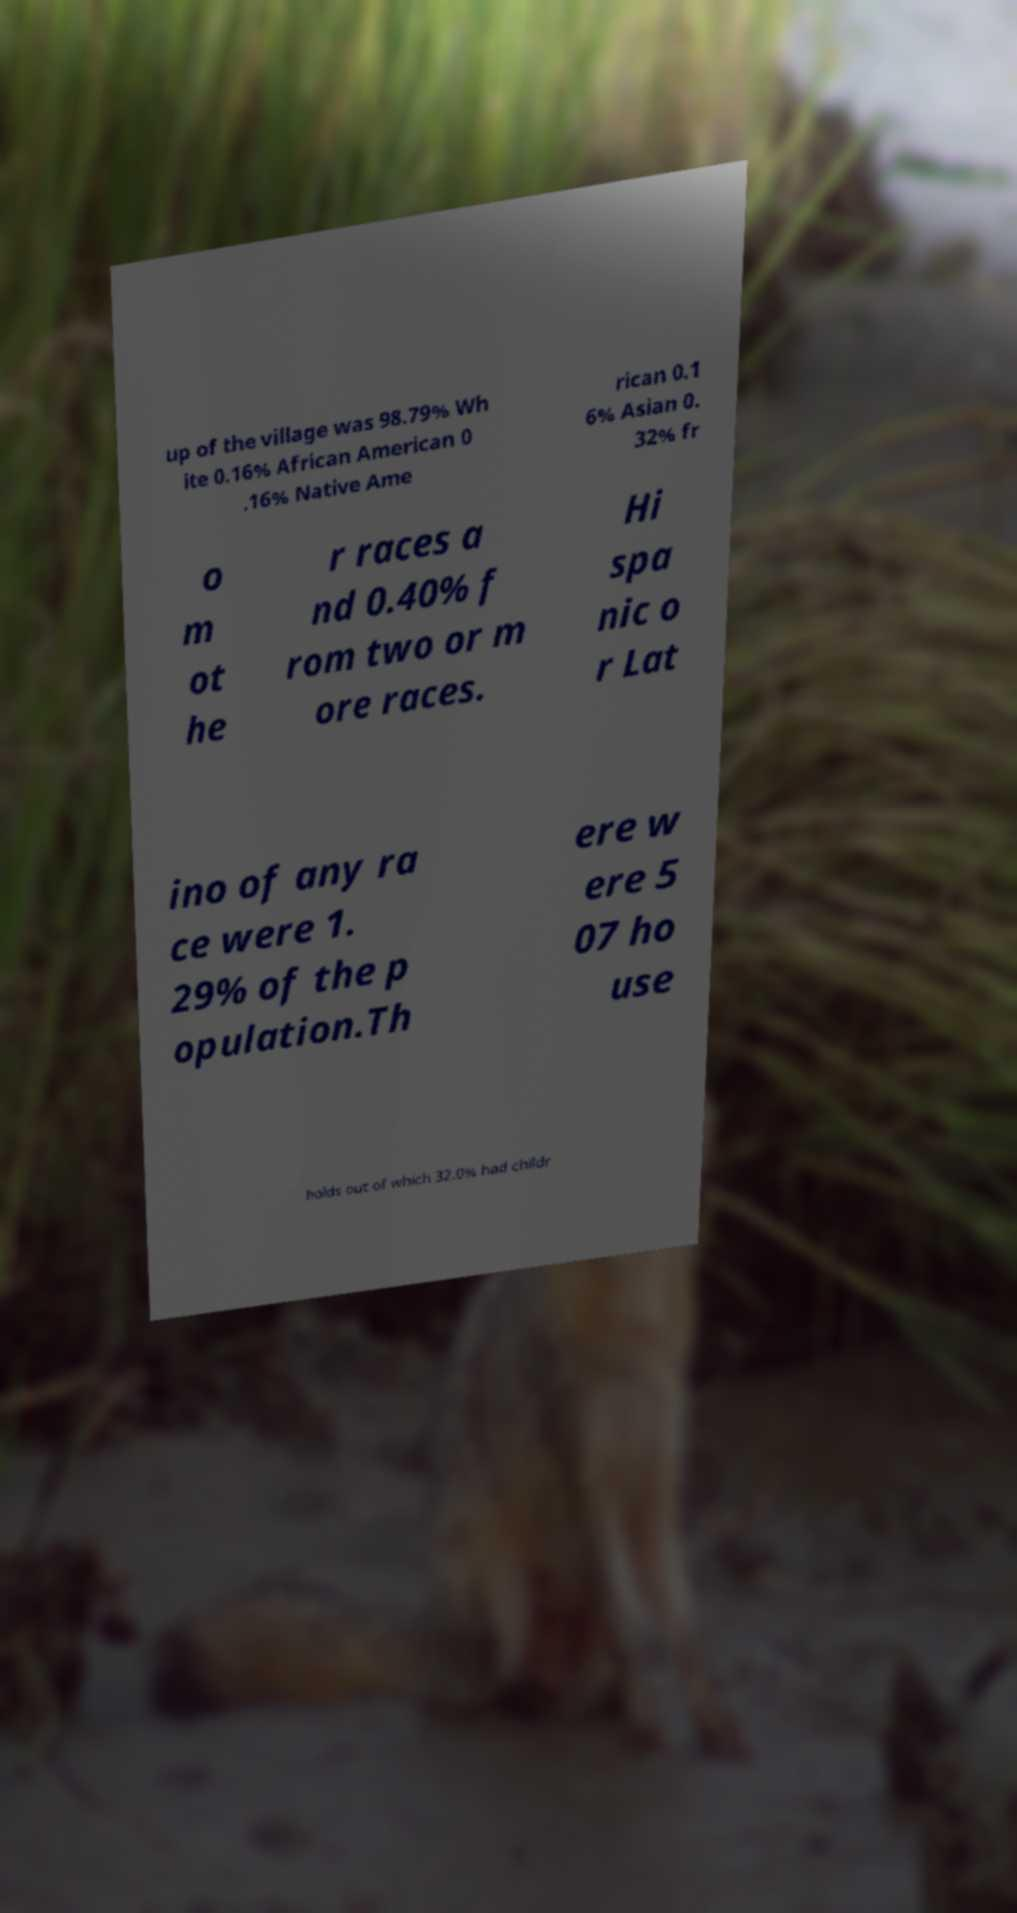Please read and relay the text visible in this image. What does it say? up of the village was 98.79% Wh ite 0.16% African American 0 .16% Native Ame rican 0.1 6% Asian 0. 32% fr o m ot he r races a nd 0.40% f rom two or m ore races. Hi spa nic o r Lat ino of any ra ce were 1. 29% of the p opulation.Th ere w ere 5 07 ho use holds out of which 32.0% had childr 